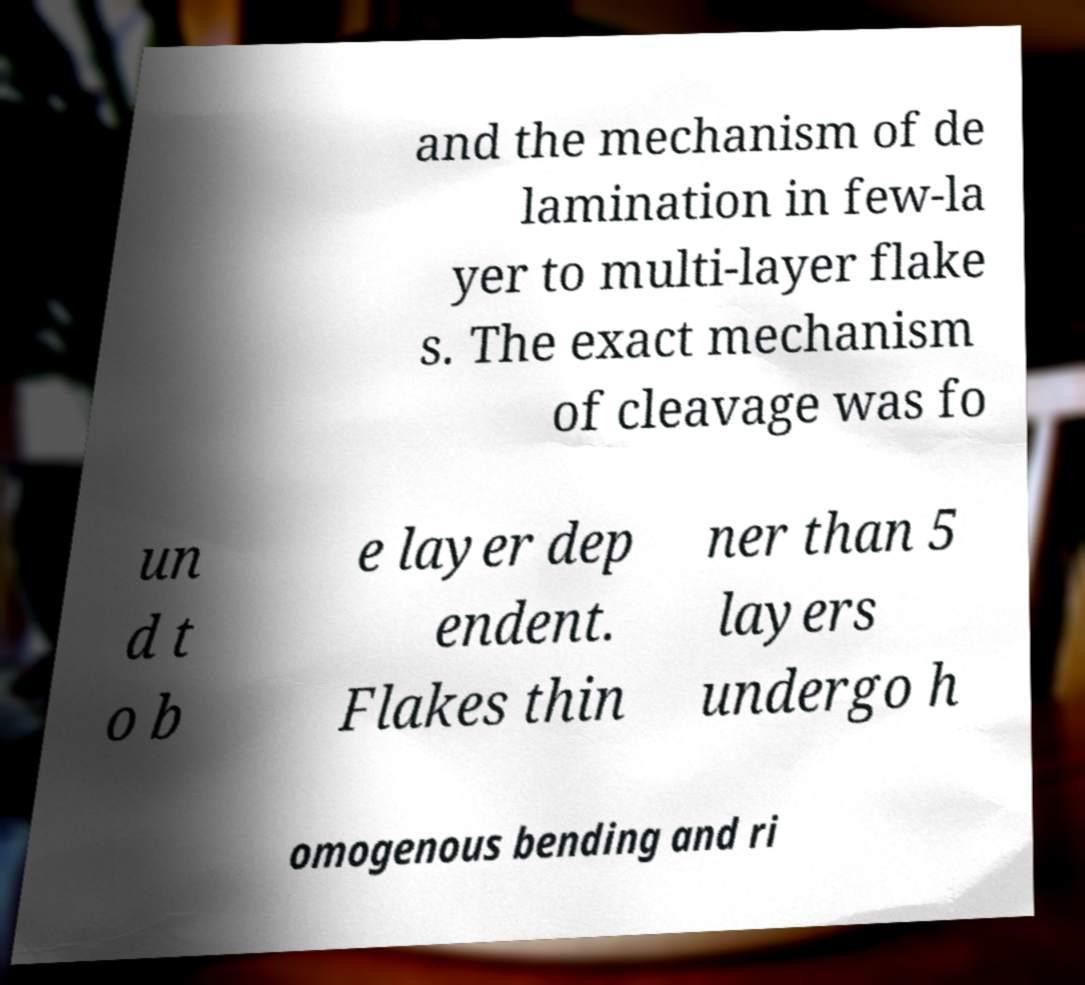Could you extract and type out the text from this image? and the mechanism of de lamination in few-la yer to multi-layer flake s. The exact mechanism of cleavage was fo un d t o b e layer dep endent. Flakes thin ner than 5 layers undergo h omogenous bending and ri 